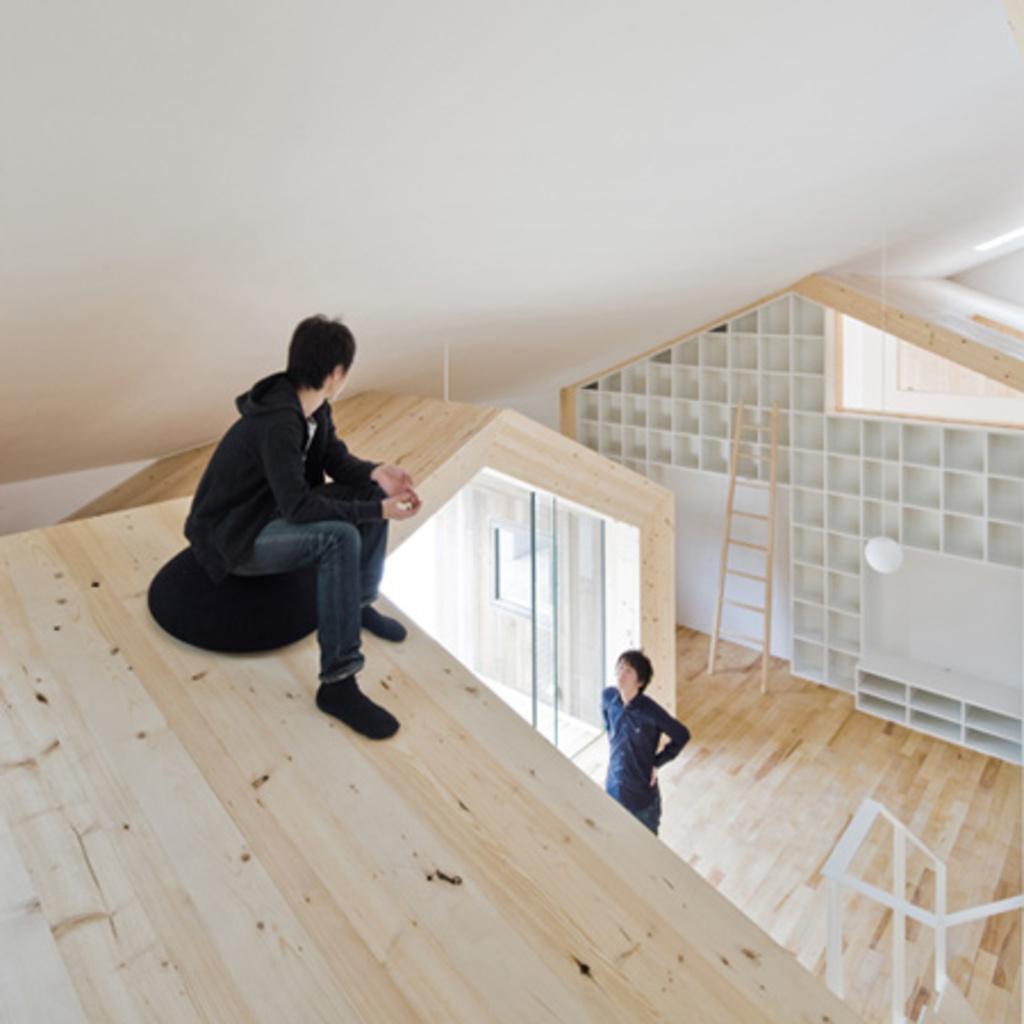Describe this image in one or two sentences. There is a person sitting on a black color object. And the object is on the wooden surface. Also there is another person standing. On the right side there is a wall with shelves. Near to that there is a ladder. 